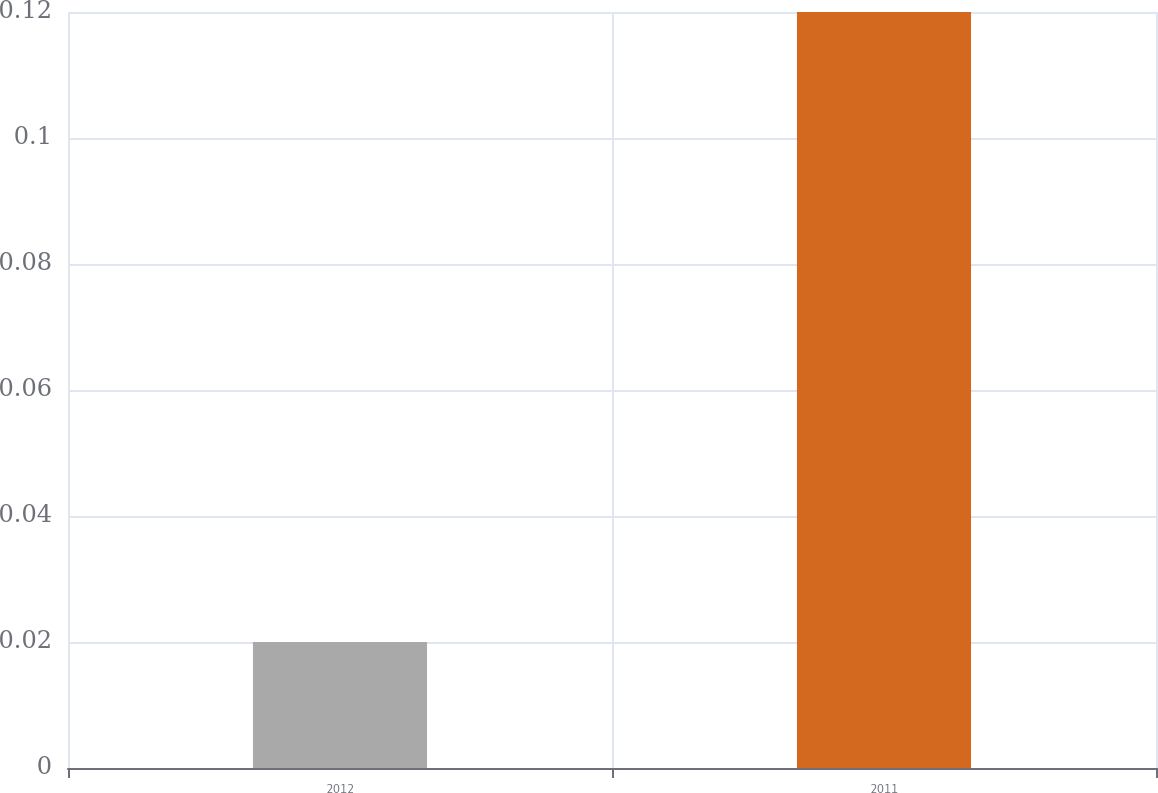Convert chart. <chart><loc_0><loc_0><loc_500><loc_500><bar_chart><fcel>2012<fcel>2011<nl><fcel>0.02<fcel>0.12<nl></chart> 